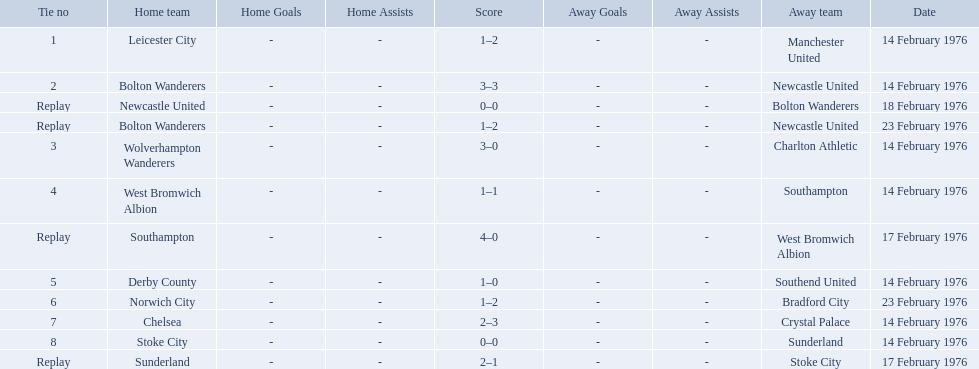What are all of the scores of the 1975-76 fa cup? 1–2, 3–3, 0–0, 1–2, 3–0, 1–1, 4–0, 1–0, 1–2, 2–3, 0–0, 2–1. What are the scores for manchester united or wolverhampton wanderers? 1–2, 3–0. Which has the highest score? 3–0. Who was this score for? Wolverhampton Wanderers. Who were all the teams that played? Leicester City, Manchester United, Bolton Wanderers, Newcastle United, Newcastle United, Bolton Wanderers, Bolton Wanderers, Newcastle United, Wolverhampton Wanderers, Charlton Athletic, West Bromwich Albion, Southampton, Southampton, West Bromwich Albion, Derby County, Southend United, Norwich City, Bradford City, Chelsea, Crystal Palace, Stoke City, Sunderland, Sunderland, Stoke City. Which of these teams won? Manchester United, Newcastle United, Wolverhampton Wanderers, Southampton, Derby County, Bradford City, Crystal Palace, Sunderland. What was manchester united's winning score? 1–2. What was the wolverhampton wonders winning score? 3–0. Which of these two teams had the better winning score? Wolverhampton Wanderers. 